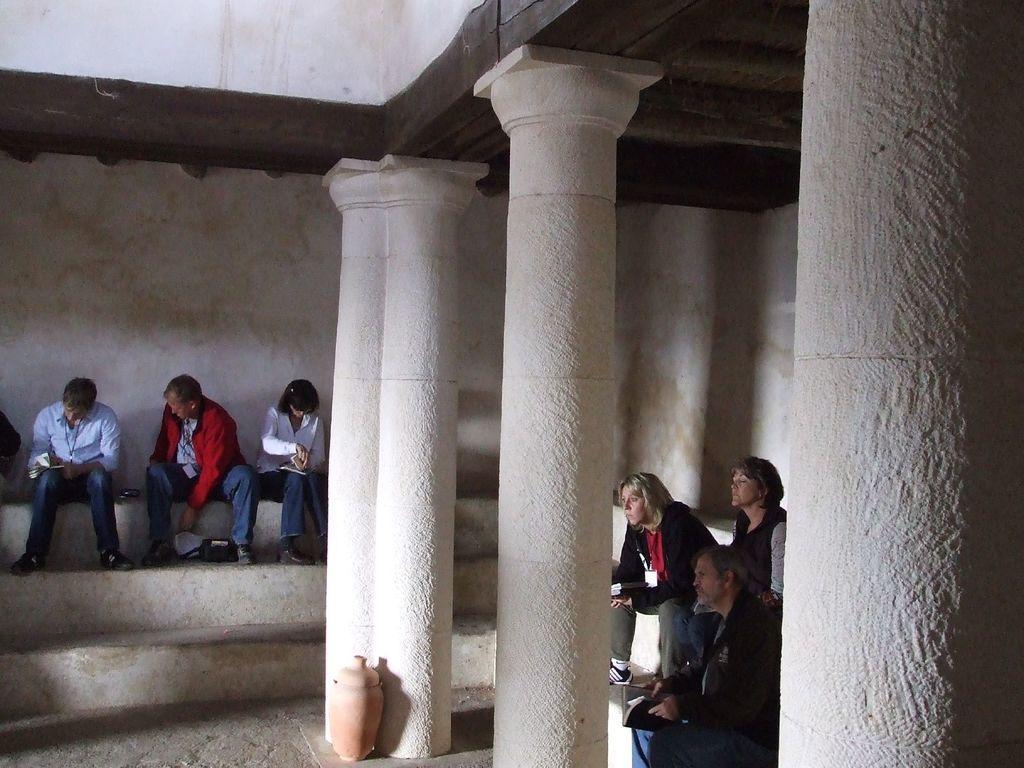In one or two sentences, can you explain what this image depicts? In this image there are staircase, there are group of personś sitting, there are pillarś, white wall behind the person. 